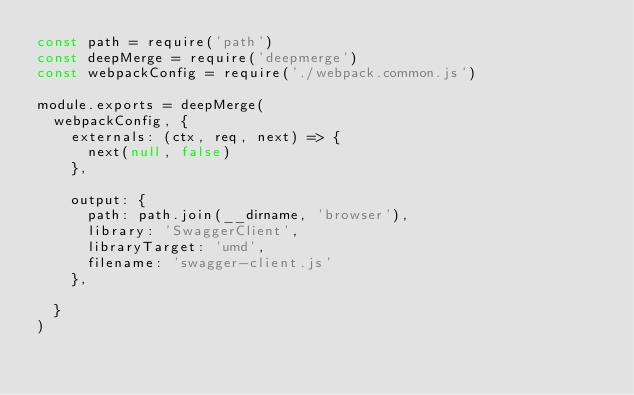Convert code to text. <code><loc_0><loc_0><loc_500><loc_500><_JavaScript_>const path = require('path')
const deepMerge = require('deepmerge')
const webpackConfig = require('./webpack.common.js')

module.exports = deepMerge(
  webpackConfig, {
    externals: (ctx, req, next) => {
      next(null, false)
    },

    output: {
      path: path.join(__dirname, 'browser'),
      library: 'SwaggerClient',
      libraryTarget: 'umd',
      filename: 'swagger-client.js'
    },

  }
)
</code> 